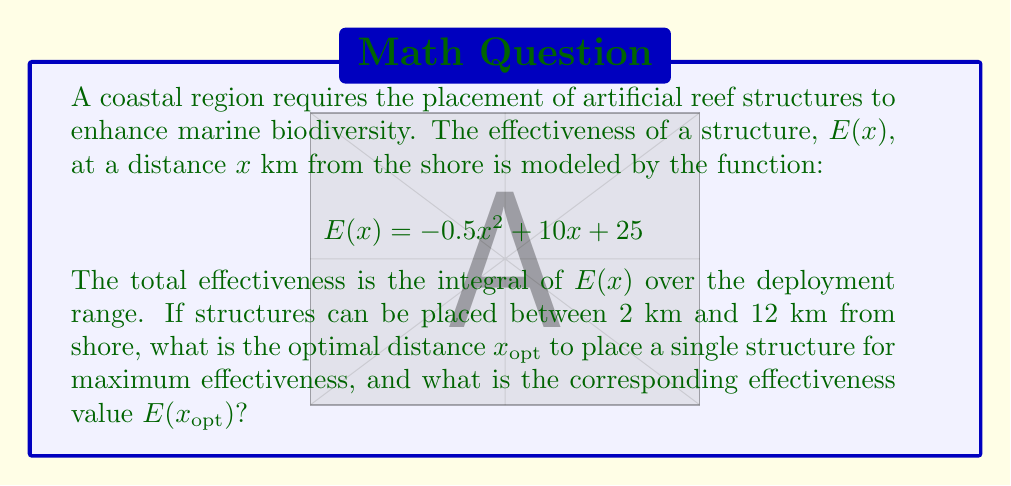Show me your answer to this math problem. To solve this inverse problem, we need to follow these steps:

1) The effectiveness function is given by:
   $$E(x) = -0.5x^2 + 10x + 25$$

2) To find the optimal distance $x_{opt}$, we need to find the maximum of this function within the given range [2, 12].

3) The maximum of a quadratic function occurs at the vertex of the parabola. We can find this by differentiating $E(x)$ and setting it to zero:

   $$\frac{dE}{dx} = -x + 10 = 0$$
   $$x = 10$$

4) This critical point $(x = 10)$ falls within our range [2, 12], so it is our $x_{opt}$.

5) To find $E(x_{opt})$, we substitute $x = 10$ into our original function:

   $$E(10) = -0.5(10)^2 + 10(10) + 25$$
   $$= -50 + 100 + 25 = 75$$

Therefore, the optimal distance to place the structure is 10 km from shore, and the corresponding effectiveness value is 75.
Answer: $x_{opt} = 10$ km, $E(x_{opt}) = 75$ 